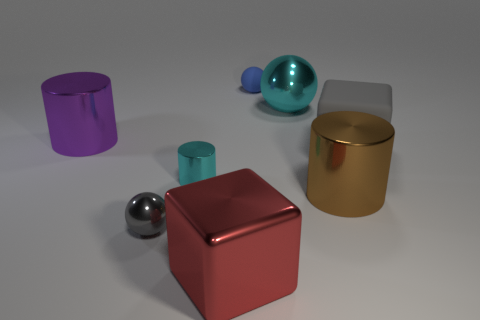Add 2 tiny blue matte balls. How many objects exist? 10 Subtract all spheres. How many objects are left? 5 Subtract all large brown cylinders. Subtract all gray rubber objects. How many objects are left? 6 Add 1 small gray objects. How many small gray objects are left? 2 Add 5 big purple metal cubes. How many big purple metal cubes exist? 5 Subtract 0 purple spheres. How many objects are left? 8 